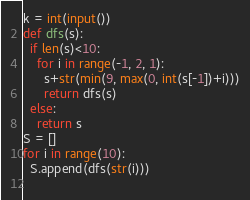Convert code to text. <code><loc_0><loc_0><loc_500><loc_500><_Python_>k = int(input())
def dfs(s):
  if len(s)<10:
    for i in range(-1, 2, 1):
      s+str(min(9, max(0, int(s[-1])+i)))
      return dfs(s)
  else:
    return s
S = []
for i in range(10):
  S.append(dfs(str(i)))
  </code> 